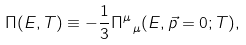Convert formula to latex. <formula><loc_0><loc_0><loc_500><loc_500>\Pi ( E , T ) \equiv - \frac { 1 } { 3 } \Pi _ { \ \mu } ^ { \mu } ( E , \vec { p } = 0 ; T ) ,</formula> 